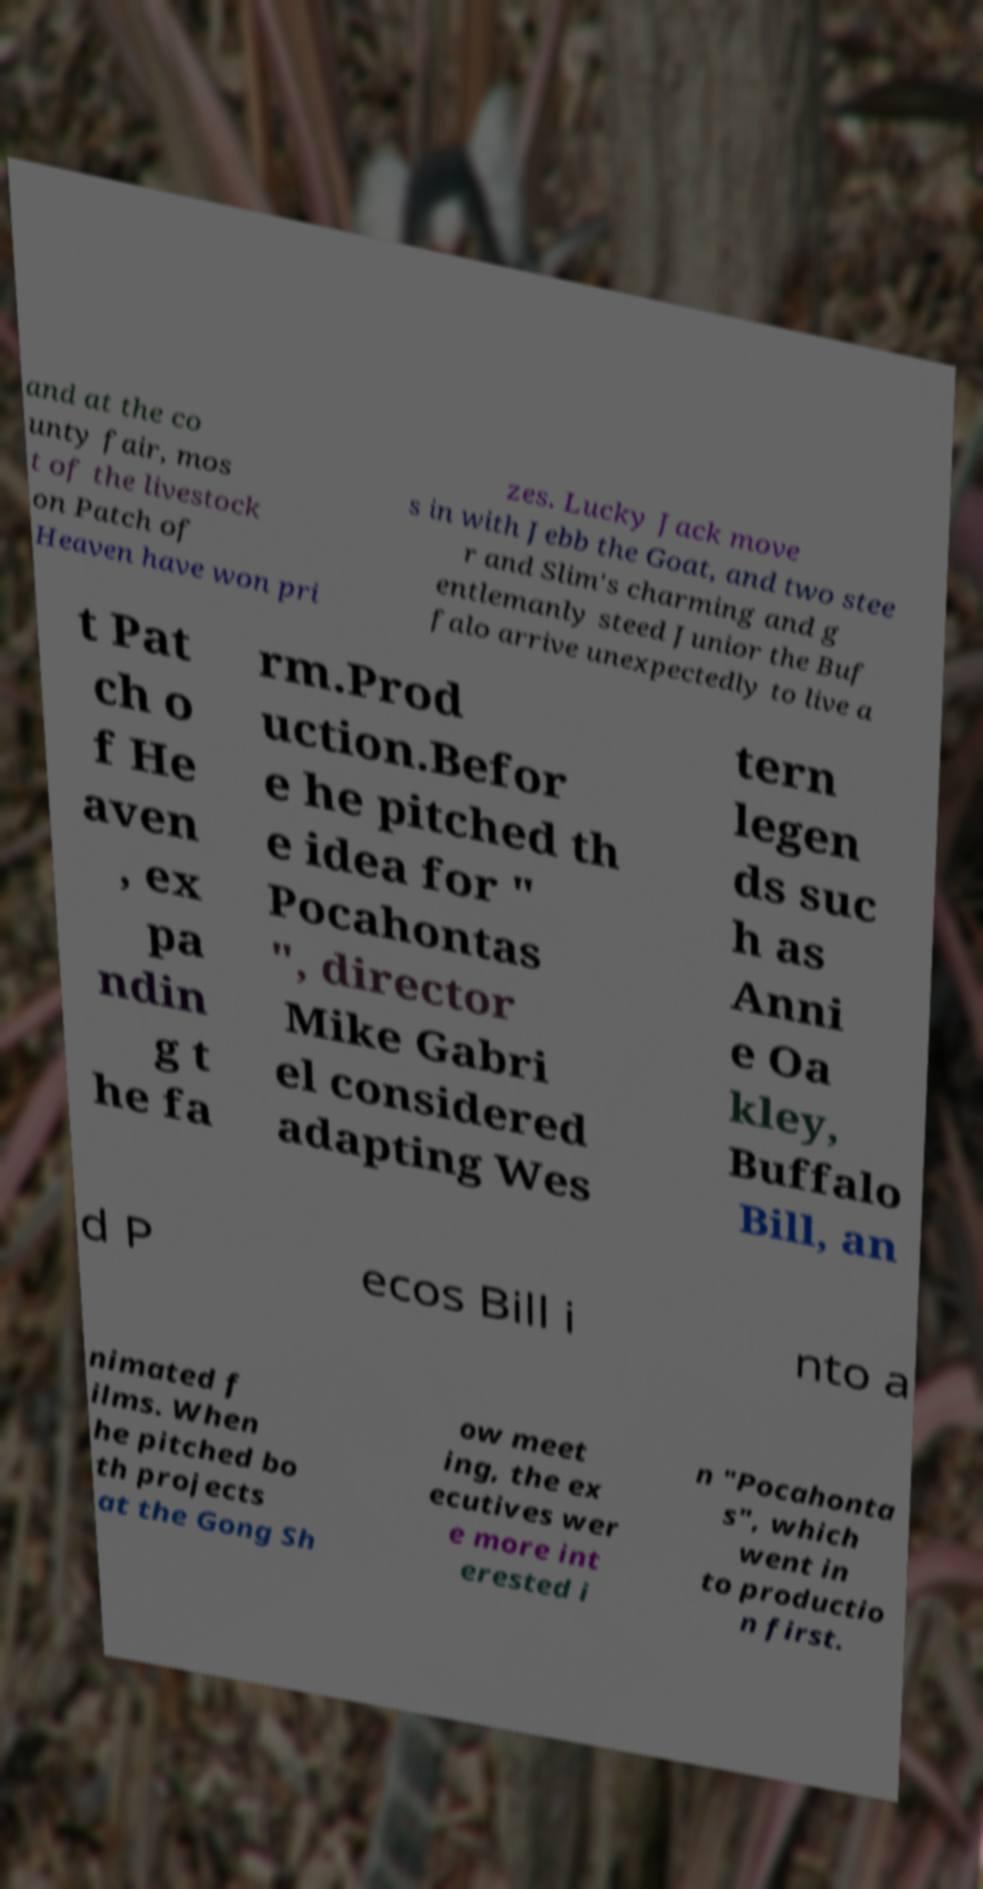Please identify and transcribe the text found in this image. and at the co unty fair, mos t of the livestock on Patch of Heaven have won pri zes. Lucky Jack move s in with Jebb the Goat, and two stee r and Slim's charming and g entlemanly steed Junior the Buf falo arrive unexpectedly to live a t Pat ch o f He aven , ex pa ndin g t he fa rm.Prod uction.Befor e he pitched th e idea for " Pocahontas ", director Mike Gabri el considered adapting Wes tern legen ds suc h as Anni e Oa kley, Buffalo Bill, an d P ecos Bill i nto a nimated f ilms. When he pitched bo th projects at the Gong Sh ow meet ing, the ex ecutives wer e more int erested i n "Pocahonta s", which went in to productio n first. 